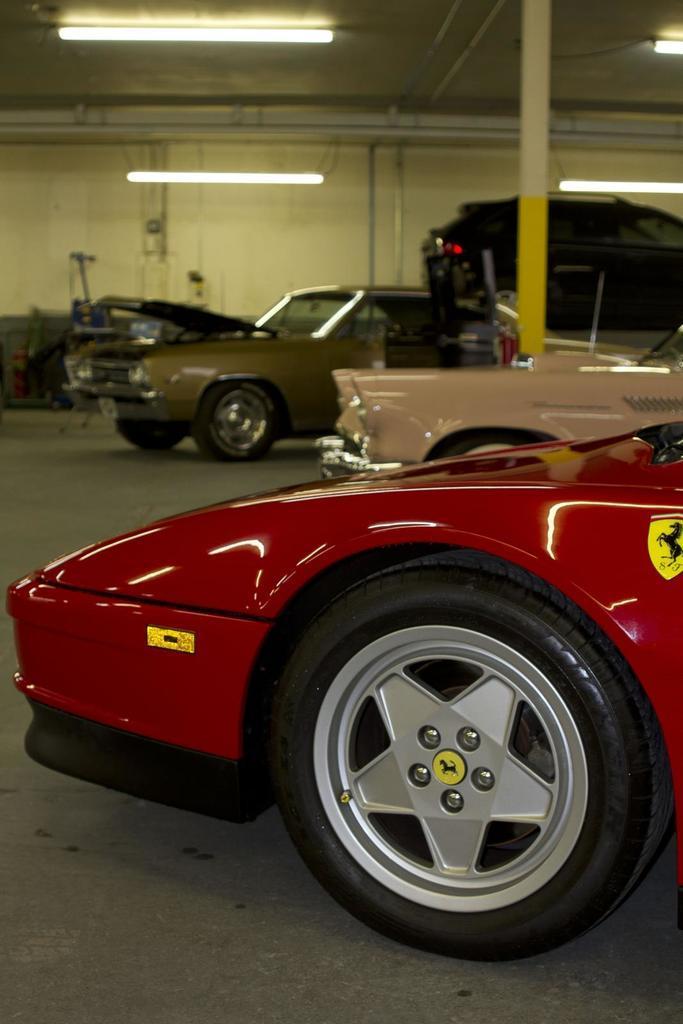Describe this image in one or two sentences. In this image I can see few cars. They are in red,cream,brown color can see pole,lights and wall. 